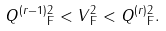Convert formula to latex. <formula><loc_0><loc_0><loc_500><loc_500>\| Q ^ { ( r - 1 ) } \| _ { \text {F} } ^ { 2 } < \| V \| _ { \text {F} } ^ { 2 } < \| Q ^ { ( r ) } \| _ { \text {F} } ^ { 2 } .</formula> 